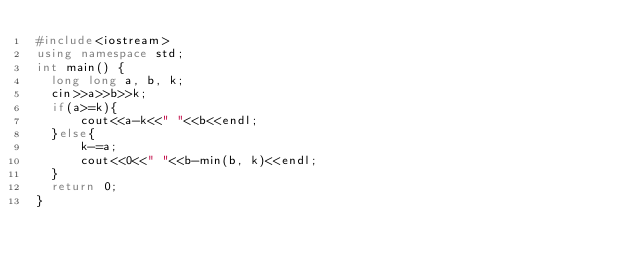Convert code to text. <code><loc_0><loc_0><loc_500><loc_500><_C++_>#include<iostream>
using namespace std;
int main() {
	long long a, b, k;
	cin>>a>>b>>k;
	if(a>=k){
	    cout<<a-k<<" "<<b<<endl;
	}else{
	    k-=a;
	    cout<<0<<" "<<b-min(b, k)<<endl;
	}
	return 0;
}</code> 